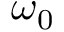<formula> <loc_0><loc_0><loc_500><loc_500>\omega _ { 0 }</formula> 